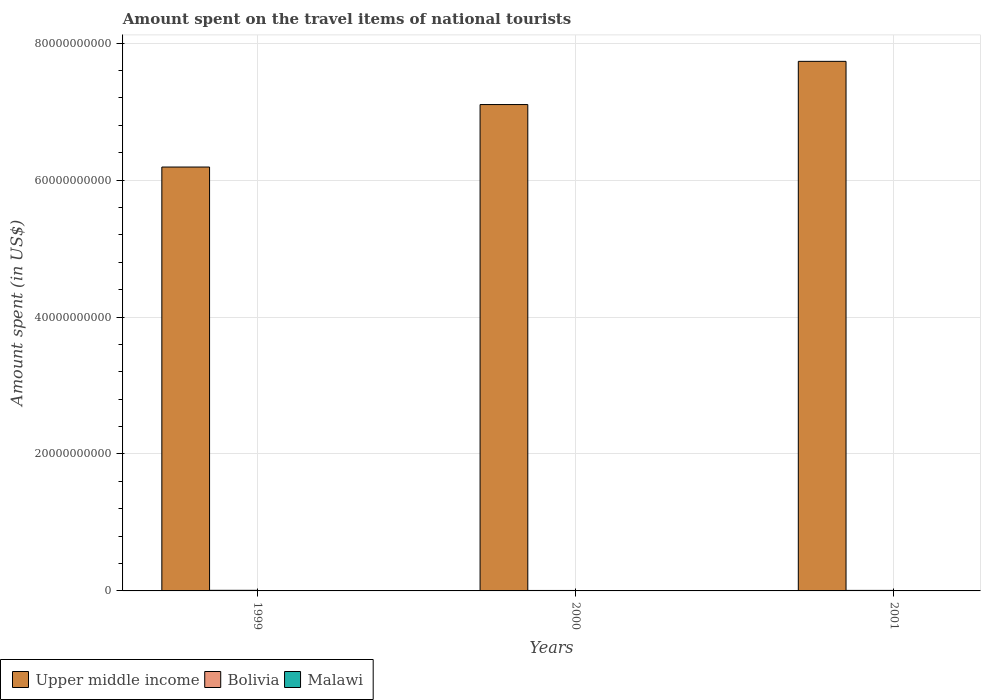How many groups of bars are there?
Offer a terse response. 3. Are the number of bars on each tick of the X-axis equal?
Your response must be concise. Yes. How many bars are there on the 1st tick from the right?
Provide a short and direct response. 3. What is the label of the 2nd group of bars from the left?
Provide a succinct answer. 2000. What is the amount spent on the travel items of national tourists in Bolivia in 1999?
Provide a succinct answer. 8.70e+07. Across all years, what is the maximum amount spent on the travel items of national tourists in Malawi?
Ensure brevity in your answer.  3.80e+07. Across all years, what is the minimum amount spent on the travel items of national tourists in Upper middle income?
Keep it short and to the point. 6.19e+1. In which year was the amount spent on the travel items of national tourists in Malawi maximum?
Offer a very short reply. 1999. In which year was the amount spent on the travel items of national tourists in Bolivia minimum?
Ensure brevity in your answer.  2000. What is the total amount spent on the travel items of national tourists in Bolivia in the graph?
Provide a succinct answer. 2.31e+08. What is the difference between the amount spent on the travel items of national tourists in Bolivia in 1999 and that in 2000?
Keep it short and to the point. 1.90e+07. What is the difference between the amount spent on the travel items of national tourists in Malawi in 2000 and the amount spent on the travel items of national tourists in Upper middle income in 2001?
Provide a short and direct response. -7.73e+1. What is the average amount spent on the travel items of national tourists in Bolivia per year?
Your answer should be very brief. 7.70e+07. In the year 2001, what is the difference between the amount spent on the travel items of national tourists in Upper middle income and amount spent on the travel items of national tourists in Bolivia?
Your response must be concise. 7.73e+1. In how many years, is the amount spent on the travel items of national tourists in Bolivia greater than 60000000000 US$?
Provide a short and direct response. 0. What is the ratio of the amount spent on the travel items of national tourists in Bolivia in 2000 to that in 2001?
Provide a succinct answer. 0.89. Is the amount spent on the travel items of national tourists in Malawi in 1999 less than that in 2000?
Make the answer very short. No. Is the difference between the amount spent on the travel items of national tourists in Upper middle income in 2000 and 2001 greater than the difference between the amount spent on the travel items of national tourists in Bolivia in 2000 and 2001?
Make the answer very short. No. What is the difference between the highest and the second highest amount spent on the travel items of national tourists in Malawi?
Keep it short and to the point. 1.30e+07. What is the difference between the highest and the lowest amount spent on the travel items of national tourists in Bolivia?
Your answer should be compact. 1.90e+07. In how many years, is the amount spent on the travel items of national tourists in Upper middle income greater than the average amount spent on the travel items of national tourists in Upper middle income taken over all years?
Make the answer very short. 2. Is the sum of the amount spent on the travel items of national tourists in Malawi in 1999 and 2000 greater than the maximum amount spent on the travel items of national tourists in Upper middle income across all years?
Your response must be concise. No. What does the 1st bar from the left in 2000 represents?
Your answer should be very brief. Upper middle income. What does the 3rd bar from the right in 1999 represents?
Your answer should be compact. Upper middle income. How many bars are there?
Your answer should be compact. 9. Are all the bars in the graph horizontal?
Offer a terse response. No. Are the values on the major ticks of Y-axis written in scientific E-notation?
Keep it short and to the point. No. Does the graph contain any zero values?
Offer a very short reply. No. Does the graph contain grids?
Give a very brief answer. Yes. What is the title of the graph?
Your answer should be compact. Amount spent on the travel items of national tourists. What is the label or title of the X-axis?
Offer a terse response. Years. What is the label or title of the Y-axis?
Make the answer very short. Amount spent (in US$). What is the Amount spent (in US$) of Upper middle income in 1999?
Your response must be concise. 6.19e+1. What is the Amount spent (in US$) in Bolivia in 1999?
Provide a succinct answer. 8.70e+07. What is the Amount spent (in US$) of Malawi in 1999?
Give a very brief answer. 3.80e+07. What is the Amount spent (in US$) in Upper middle income in 2000?
Give a very brief answer. 7.10e+1. What is the Amount spent (in US$) of Bolivia in 2000?
Give a very brief answer. 6.80e+07. What is the Amount spent (in US$) of Malawi in 2000?
Provide a short and direct response. 2.50e+07. What is the Amount spent (in US$) in Upper middle income in 2001?
Offer a very short reply. 7.74e+1. What is the Amount spent (in US$) in Bolivia in 2001?
Offer a very short reply. 7.60e+07. What is the Amount spent (in US$) in Malawi in 2001?
Your response must be concise. 2.50e+07. Across all years, what is the maximum Amount spent (in US$) in Upper middle income?
Your answer should be very brief. 7.74e+1. Across all years, what is the maximum Amount spent (in US$) of Bolivia?
Offer a very short reply. 8.70e+07. Across all years, what is the maximum Amount spent (in US$) of Malawi?
Provide a succinct answer. 3.80e+07. Across all years, what is the minimum Amount spent (in US$) in Upper middle income?
Provide a succinct answer. 6.19e+1. Across all years, what is the minimum Amount spent (in US$) of Bolivia?
Offer a very short reply. 6.80e+07. Across all years, what is the minimum Amount spent (in US$) in Malawi?
Provide a short and direct response. 2.50e+07. What is the total Amount spent (in US$) of Upper middle income in the graph?
Ensure brevity in your answer.  2.10e+11. What is the total Amount spent (in US$) of Bolivia in the graph?
Provide a short and direct response. 2.31e+08. What is the total Amount spent (in US$) of Malawi in the graph?
Your answer should be very brief. 8.80e+07. What is the difference between the Amount spent (in US$) of Upper middle income in 1999 and that in 2000?
Ensure brevity in your answer.  -9.13e+09. What is the difference between the Amount spent (in US$) in Bolivia in 1999 and that in 2000?
Provide a short and direct response. 1.90e+07. What is the difference between the Amount spent (in US$) in Malawi in 1999 and that in 2000?
Offer a very short reply. 1.30e+07. What is the difference between the Amount spent (in US$) of Upper middle income in 1999 and that in 2001?
Ensure brevity in your answer.  -1.54e+1. What is the difference between the Amount spent (in US$) in Bolivia in 1999 and that in 2001?
Give a very brief answer. 1.10e+07. What is the difference between the Amount spent (in US$) in Malawi in 1999 and that in 2001?
Ensure brevity in your answer.  1.30e+07. What is the difference between the Amount spent (in US$) in Upper middle income in 2000 and that in 2001?
Make the answer very short. -6.31e+09. What is the difference between the Amount spent (in US$) of Bolivia in 2000 and that in 2001?
Your answer should be very brief. -8.00e+06. What is the difference between the Amount spent (in US$) in Malawi in 2000 and that in 2001?
Your answer should be very brief. 0. What is the difference between the Amount spent (in US$) of Upper middle income in 1999 and the Amount spent (in US$) of Bolivia in 2000?
Make the answer very short. 6.18e+1. What is the difference between the Amount spent (in US$) in Upper middle income in 1999 and the Amount spent (in US$) in Malawi in 2000?
Offer a terse response. 6.19e+1. What is the difference between the Amount spent (in US$) of Bolivia in 1999 and the Amount spent (in US$) of Malawi in 2000?
Your response must be concise. 6.20e+07. What is the difference between the Amount spent (in US$) in Upper middle income in 1999 and the Amount spent (in US$) in Bolivia in 2001?
Offer a very short reply. 6.18e+1. What is the difference between the Amount spent (in US$) in Upper middle income in 1999 and the Amount spent (in US$) in Malawi in 2001?
Give a very brief answer. 6.19e+1. What is the difference between the Amount spent (in US$) of Bolivia in 1999 and the Amount spent (in US$) of Malawi in 2001?
Offer a very short reply. 6.20e+07. What is the difference between the Amount spent (in US$) of Upper middle income in 2000 and the Amount spent (in US$) of Bolivia in 2001?
Your answer should be very brief. 7.10e+1. What is the difference between the Amount spent (in US$) of Upper middle income in 2000 and the Amount spent (in US$) of Malawi in 2001?
Your response must be concise. 7.10e+1. What is the difference between the Amount spent (in US$) of Bolivia in 2000 and the Amount spent (in US$) of Malawi in 2001?
Provide a short and direct response. 4.30e+07. What is the average Amount spent (in US$) in Upper middle income per year?
Offer a very short reply. 7.01e+1. What is the average Amount spent (in US$) of Bolivia per year?
Your response must be concise. 7.70e+07. What is the average Amount spent (in US$) of Malawi per year?
Provide a succinct answer. 2.93e+07. In the year 1999, what is the difference between the Amount spent (in US$) in Upper middle income and Amount spent (in US$) in Bolivia?
Provide a succinct answer. 6.18e+1. In the year 1999, what is the difference between the Amount spent (in US$) of Upper middle income and Amount spent (in US$) of Malawi?
Your response must be concise. 6.19e+1. In the year 1999, what is the difference between the Amount spent (in US$) in Bolivia and Amount spent (in US$) in Malawi?
Keep it short and to the point. 4.90e+07. In the year 2000, what is the difference between the Amount spent (in US$) in Upper middle income and Amount spent (in US$) in Bolivia?
Provide a short and direct response. 7.10e+1. In the year 2000, what is the difference between the Amount spent (in US$) in Upper middle income and Amount spent (in US$) in Malawi?
Your answer should be very brief. 7.10e+1. In the year 2000, what is the difference between the Amount spent (in US$) in Bolivia and Amount spent (in US$) in Malawi?
Offer a terse response. 4.30e+07. In the year 2001, what is the difference between the Amount spent (in US$) in Upper middle income and Amount spent (in US$) in Bolivia?
Your answer should be very brief. 7.73e+1. In the year 2001, what is the difference between the Amount spent (in US$) of Upper middle income and Amount spent (in US$) of Malawi?
Offer a terse response. 7.73e+1. In the year 2001, what is the difference between the Amount spent (in US$) in Bolivia and Amount spent (in US$) in Malawi?
Keep it short and to the point. 5.10e+07. What is the ratio of the Amount spent (in US$) in Upper middle income in 1999 to that in 2000?
Give a very brief answer. 0.87. What is the ratio of the Amount spent (in US$) of Bolivia in 1999 to that in 2000?
Give a very brief answer. 1.28. What is the ratio of the Amount spent (in US$) of Malawi in 1999 to that in 2000?
Give a very brief answer. 1.52. What is the ratio of the Amount spent (in US$) in Upper middle income in 1999 to that in 2001?
Make the answer very short. 0.8. What is the ratio of the Amount spent (in US$) in Bolivia in 1999 to that in 2001?
Ensure brevity in your answer.  1.14. What is the ratio of the Amount spent (in US$) of Malawi in 1999 to that in 2001?
Offer a very short reply. 1.52. What is the ratio of the Amount spent (in US$) in Upper middle income in 2000 to that in 2001?
Offer a very short reply. 0.92. What is the ratio of the Amount spent (in US$) in Bolivia in 2000 to that in 2001?
Your answer should be compact. 0.89. What is the ratio of the Amount spent (in US$) of Malawi in 2000 to that in 2001?
Offer a very short reply. 1. What is the difference between the highest and the second highest Amount spent (in US$) of Upper middle income?
Provide a short and direct response. 6.31e+09. What is the difference between the highest and the second highest Amount spent (in US$) of Bolivia?
Keep it short and to the point. 1.10e+07. What is the difference between the highest and the second highest Amount spent (in US$) of Malawi?
Your response must be concise. 1.30e+07. What is the difference between the highest and the lowest Amount spent (in US$) of Upper middle income?
Offer a terse response. 1.54e+1. What is the difference between the highest and the lowest Amount spent (in US$) in Bolivia?
Provide a succinct answer. 1.90e+07. What is the difference between the highest and the lowest Amount spent (in US$) of Malawi?
Give a very brief answer. 1.30e+07. 